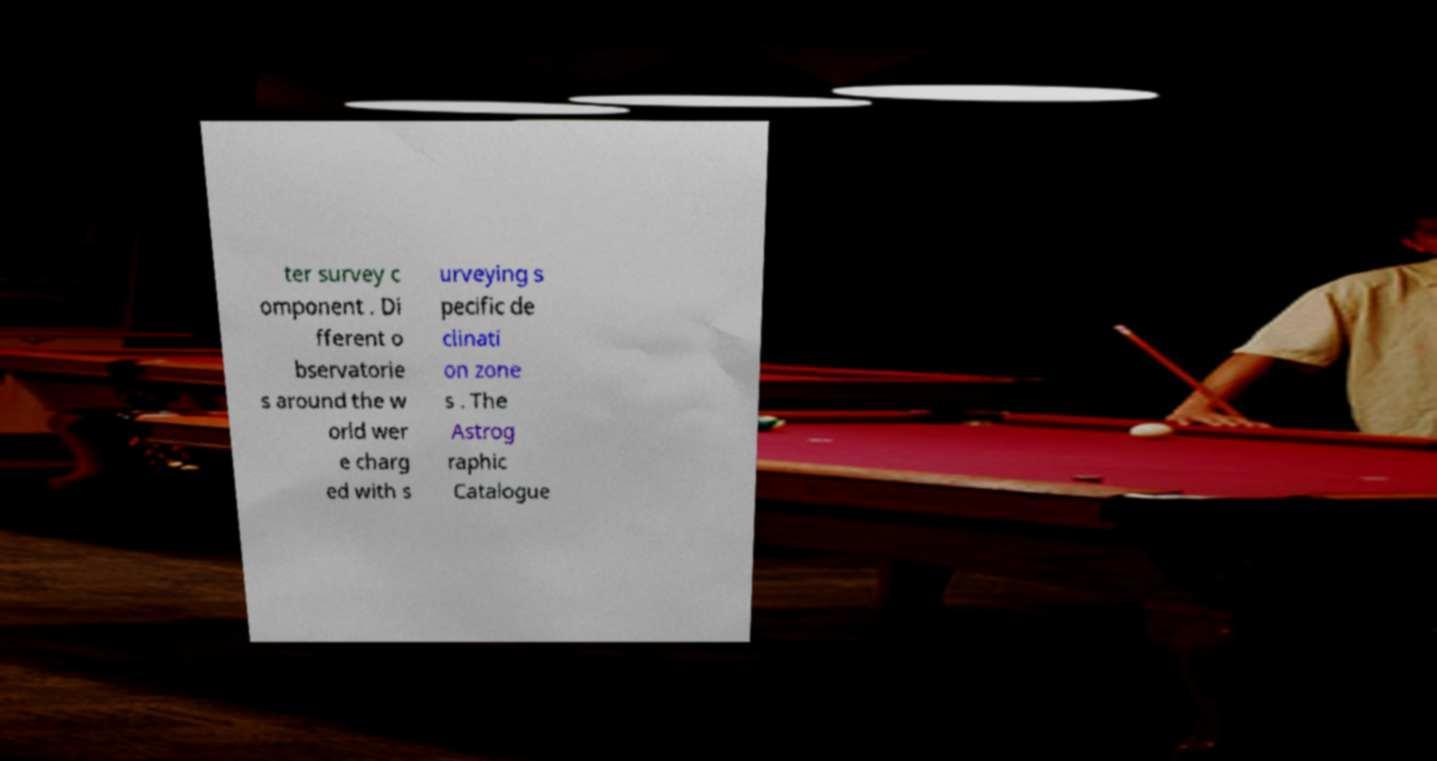For documentation purposes, I need the text within this image transcribed. Could you provide that? ter survey c omponent . Di fferent o bservatorie s around the w orld wer e charg ed with s urveying s pecific de clinati on zone s . The Astrog raphic Catalogue 